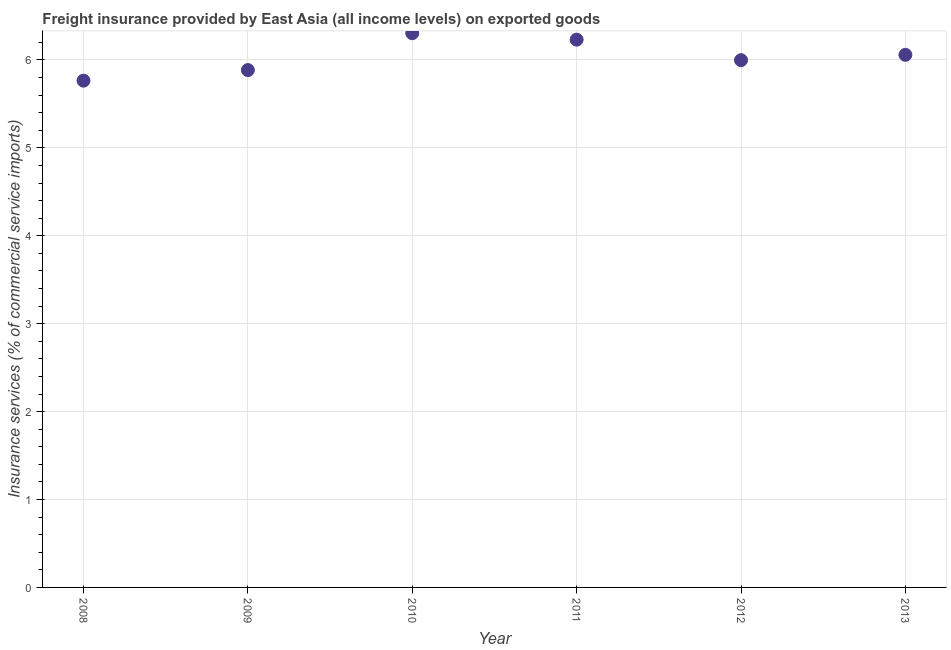What is the freight insurance in 2011?
Offer a very short reply. 6.23. Across all years, what is the maximum freight insurance?
Provide a short and direct response. 6.3. Across all years, what is the minimum freight insurance?
Offer a very short reply. 5.76. In which year was the freight insurance maximum?
Give a very brief answer. 2010. In which year was the freight insurance minimum?
Give a very brief answer. 2008. What is the sum of the freight insurance?
Your answer should be compact. 36.24. What is the difference between the freight insurance in 2009 and 2010?
Your response must be concise. -0.42. What is the average freight insurance per year?
Your answer should be very brief. 6.04. What is the median freight insurance?
Offer a very short reply. 6.03. In how many years, is the freight insurance greater than 0.6000000000000001 %?
Make the answer very short. 6. What is the ratio of the freight insurance in 2009 to that in 2013?
Your answer should be very brief. 0.97. What is the difference between the highest and the second highest freight insurance?
Give a very brief answer. 0.07. What is the difference between the highest and the lowest freight insurance?
Offer a very short reply. 0.54. In how many years, is the freight insurance greater than the average freight insurance taken over all years?
Provide a short and direct response. 3. How many years are there in the graph?
Provide a succinct answer. 6. Are the values on the major ticks of Y-axis written in scientific E-notation?
Your answer should be compact. No. Does the graph contain any zero values?
Offer a very short reply. No. What is the title of the graph?
Your answer should be very brief. Freight insurance provided by East Asia (all income levels) on exported goods . What is the label or title of the X-axis?
Offer a terse response. Year. What is the label or title of the Y-axis?
Offer a very short reply. Insurance services (% of commercial service imports). What is the Insurance services (% of commercial service imports) in 2008?
Provide a short and direct response. 5.76. What is the Insurance services (% of commercial service imports) in 2009?
Ensure brevity in your answer.  5.89. What is the Insurance services (% of commercial service imports) in 2010?
Your answer should be compact. 6.3. What is the Insurance services (% of commercial service imports) in 2011?
Keep it short and to the point. 6.23. What is the Insurance services (% of commercial service imports) in 2012?
Your answer should be compact. 6. What is the Insurance services (% of commercial service imports) in 2013?
Ensure brevity in your answer.  6.06. What is the difference between the Insurance services (% of commercial service imports) in 2008 and 2009?
Your response must be concise. -0.12. What is the difference between the Insurance services (% of commercial service imports) in 2008 and 2010?
Your response must be concise. -0.54. What is the difference between the Insurance services (% of commercial service imports) in 2008 and 2011?
Offer a very short reply. -0.47. What is the difference between the Insurance services (% of commercial service imports) in 2008 and 2012?
Offer a terse response. -0.23. What is the difference between the Insurance services (% of commercial service imports) in 2008 and 2013?
Offer a terse response. -0.29. What is the difference between the Insurance services (% of commercial service imports) in 2009 and 2010?
Keep it short and to the point. -0.42. What is the difference between the Insurance services (% of commercial service imports) in 2009 and 2011?
Provide a succinct answer. -0.35. What is the difference between the Insurance services (% of commercial service imports) in 2009 and 2012?
Your answer should be very brief. -0.11. What is the difference between the Insurance services (% of commercial service imports) in 2009 and 2013?
Offer a terse response. -0.17. What is the difference between the Insurance services (% of commercial service imports) in 2010 and 2011?
Provide a short and direct response. 0.07. What is the difference between the Insurance services (% of commercial service imports) in 2010 and 2012?
Keep it short and to the point. 0.31. What is the difference between the Insurance services (% of commercial service imports) in 2010 and 2013?
Ensure brevity in your answer.  0.25. What is the difference between the Insurance services (% of commercial service imports) in 2011 and 2012?
Keep it short and to the point. 0.23. What is the difference between the Insurance services (% of commercial service imports) in 2011 and 2013?
Offer a terse response. 0.17. What is the difference between the Insurance services (% of commercial service imports) in 2012 and 2013?
Provide a succinct answer. -0.06. What is the ratio of the Insurance services (% of commercial service imports) in 2008 to that in 2010?
Make the answer very short. 0.91. What is the ratio of the Insurance services (% of commercial service imports) in 2008 to that in 2011?
Offer a very short reply. 0.93. What is the ratio of the Insurance services (% of commercial service imports) in 2008 to that in 2013?
Provide a short and direct response. 0.95. What is the ratio of the Insurance services (% of commercial service imports) in 2009 to that in 2010?
Provide a short and direct response. 0.93. What is the ratio of the Insurance services (% of commercial service imports) in 2009 to that in 2011?
Provide a succinct answer. 0.94. What is the ratio of the Insurance services (% of commercial service imports) in 2009 to that in 2013?
Offer a very short reply. 0.97. What is the ratio of the Insurance services (% of commercial service imports) in 2010 to that in 2012?
Your answer should be very brief. 1.05. What is the ratio of the Insurance services (% of commercial service imports) in 2010 to that in 2013?
Provide a succinct answer. 1.04. What is the ratio of the Insurance services (% of commercial service imports) in 2011 to that in 2012?
Offer a terse response. 1.04. What is the ratio of the Insurance services (% of commercial service imports) in 2011 to that in 2013?
Make the answer very short. 1.03. 